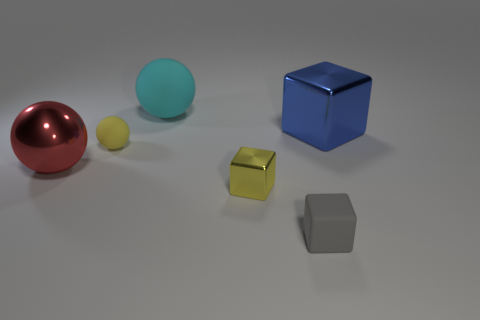Is there a pattern to how the objects are arranged? The objects seem to be arranged in a diagonal line across the image, from the red sphere on the left to the grey cube on the right. This arrangement provides a sense of balance and leads the viewer's eye across the frame. 